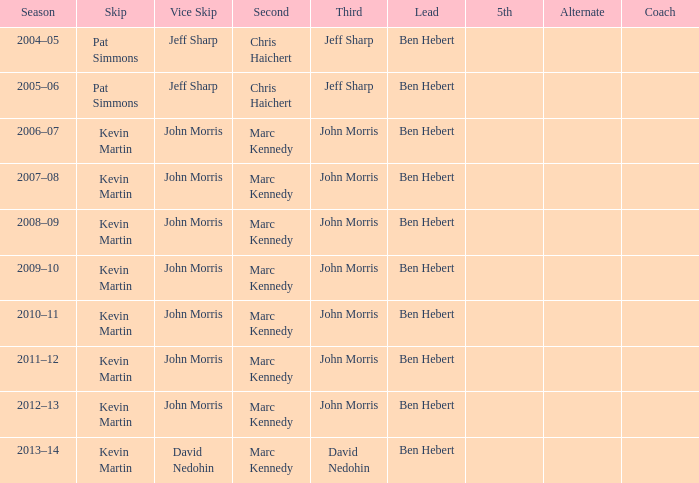What lead has the third David Nedohin? Ben Hebert. I'm looking to parse the entire table for insights. Could you assist me with that? {'header': ['Season', 'Skip', 'Vice Skip', 'Second', 'Third', 'Lead', '5th', 'Alternate', 'Coach'], 'rows': [['2004–05', 'Pat Simmons', 'Jeff Sharp', 'Chris Haichert', 'Jeff Sharp', 'Ben Hebert', '', '', ''], ['2005–06', 'Pat Simmons', 'Jeff Sharp', 'Chris Haichert', 'Jeff Sharp', 'Ben Hebert', '', '', ''], ['2006–07', 'Kevin Martin', 'John Morris', 'Marc Kennedy', 'John Morris', 'Ben Hebert', '', '', ''], ['2007–08', 'Kevin Martin', 'John Morris', 'Marc Kennedy', 'John Morris', 'Ben Hebert', '', '', ''], ['2008–09', 'Kevin Martin', 'John Morris', 'Marc Kennedy', 'John Morris', 'Ben Hebert', '', '', ''], ['2009–10', 'Kevin Martin', 'John Morris', 'Marc Kennedy', 'John Morris', 'Ben Hebert', '', '', ''], ['2010–11', 'Kevin Martin', 'John Morris', 'Marc Kennedy', 'John Morris', 'Ben Hebert', '', '', ''], ['2011–12', 'Kevin Martin', 'John Morris', 'Marc Kennedy', 'John Morris', 'Ben Hebert', '', '', ''], ['2012–13', 'Kevin Martin', 'John Morris', 'Marc Kennedy', 'John Morris', 'Ben Hebert', '', '', ''], ['2013–14', 'Kevin Martin', 'David Nedohin', 'Marc Kennedy', 'David Nedohin', 'Ben Hebert', '', '', '']]} 